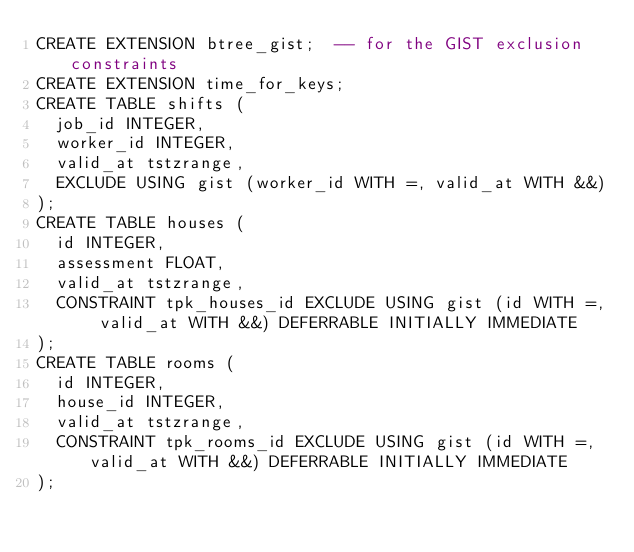Convert code to text. <code><loc_0><loc_0><loc_500><loc_500><_SQL_>CREATE EXTENSION btree_gist;  -- for the GIST exclusion constraints
CREATE EXTENSION time_for_keys;
CREATE TABLE shifts (
  job_id INTEGER,
  worker_id INTEGER,
  valid_at tstzrange,
  EXCLUDE USING gist (worker_id WITH =, valid_at WITH &&)
);
CREATE TABLE houses (
  id INTEGER,
  assessment FLOAT,
  valid_at tstzrange,
  CONSTRAINT tpk_houses_id EXCLUDE USING gist (id WITH =, valid_at WITH &&) DEFERRABLE INITIALLY IMMEDIATE
);
CREATE TABLE rooms (
  id INTEGER,
  house_id INTEGER,
  valid_at tstzrange,
  CONSTRAINT tpk_rooms_id EXCLUDE USING gist (id WITH =, valid_at WITH &&) DEFERRABLE INITIALLY IMMEDIATE
);
</code> 